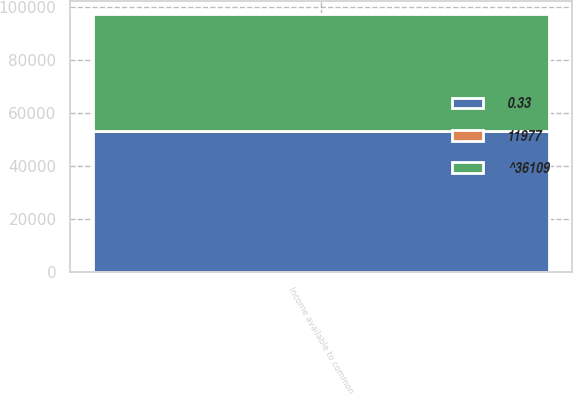Convert chart. <chart><loc_0><loc_0><loc_500><loc_500><stacked_bar_chart><ecel><fcel>Income available to common<nl><fcel>0.33<fcel>53358<nl><fcel>^36109<fcel>44000<nl><fcel>11977<fcel>1.21<nl></chart> 